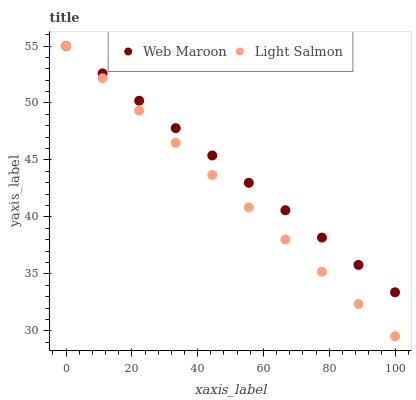Does Light Salmon have the minimum area under the curve?
Answer yes or no. Yes. Does Web Maroon have the maximum area under the curve?
Answer yes or no. Yes. Does Web Maroon have the minimum area under the curve?
Answer yes or no. No. Is Web Maroon the smoothest?
Answer yes or no. Yes. Is Light Salmon the roughest?
Answer yes or no. Yes. Is Web Maroon the roughest?
Answer yes or no. No. Does Light Salmon have the lowest value?
Answer yes or no. Yes. Does Web Maroon have the lowest value?
Answer yes or no. No. Does Web Maroon have the highest value?
Answer yes or no. Yes. Does Web Maroon intersect Light Salmon?
Answer yes or no. Yes. Is Web Maroon less than Light Salmon?
Answer yes or no. No. Is Web Maroon greater than Light Salmon?
Answer yes or no. No. 